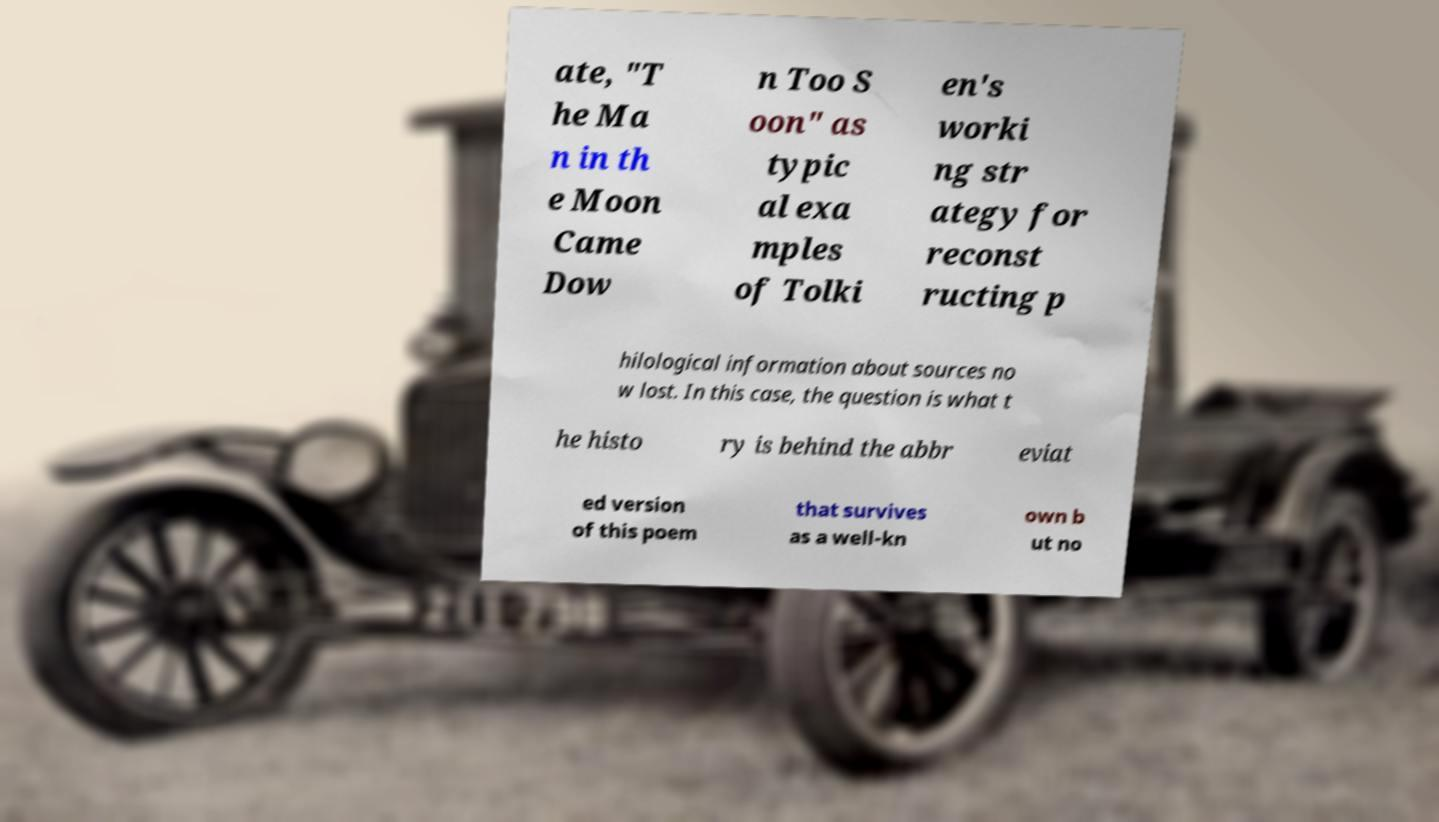Please read and relay the text visible in this image. What does it say? ate, "T he Ma n in th e Moon Came Dow n Too S oon" as typic al exa mples of Tolki en's worki ng str ategy for reconst ructing p hilological information about sources no w lost. In this case, the question is what t he histo ry is behind the abbr eviat ed version of this poem that survives as a well-kn own b ut no 